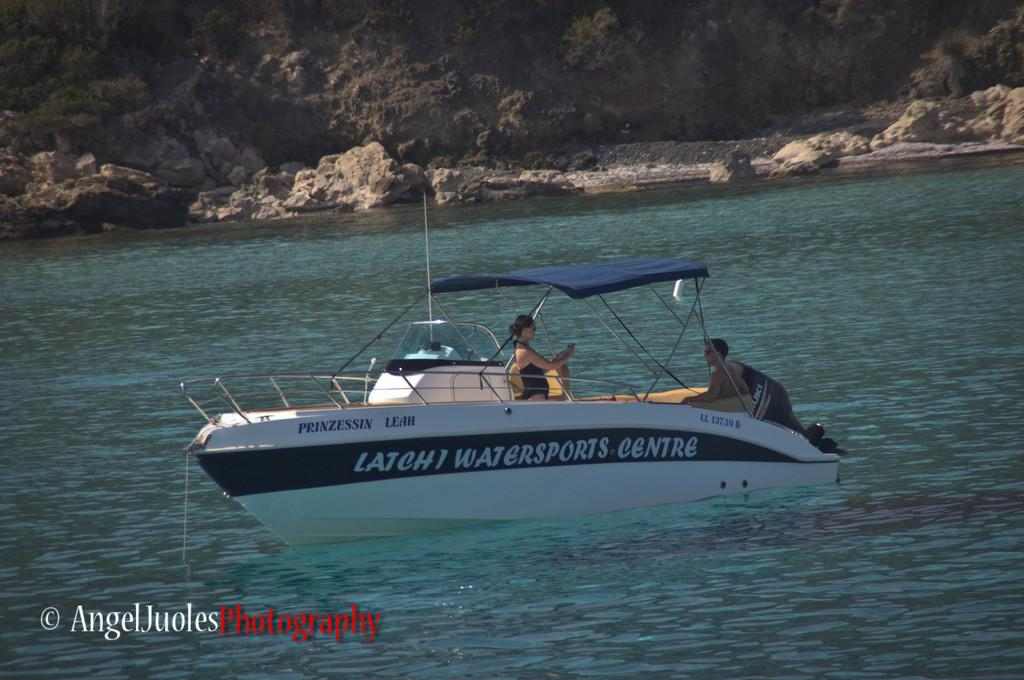How many people are in the image? There are two people in the image. What are the two people doing in the image? The two people are in a boat. Where is the boat located in the image? The boat is in the water. What other objects or features can be seen in the image? There are stones visible in the image. Is there any text or logo visible on the image? Yes, the image has a watermark. How many bikes are visible in the image? There are no bikes present in the image. What type of mine can be seen in the image? There is no mine present in the image. 